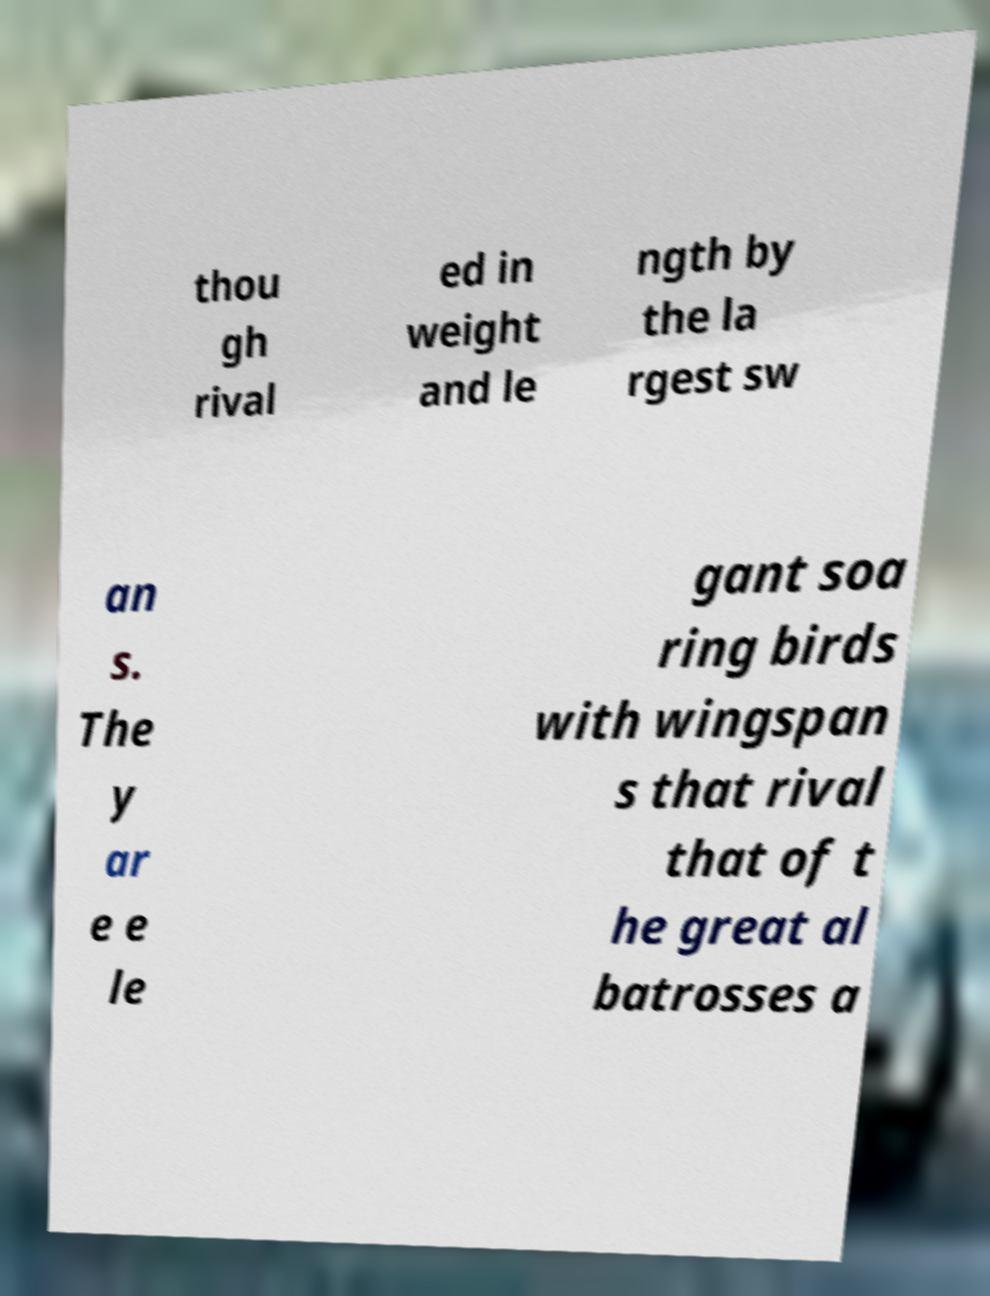Can you read and provide the text displayed in the image?This photo seems to have some interesting text. Can you extract and type it out for me? thou gh rival ed in weight and le ngth by the la rgest sw an s. The y ar e e le gant soa ring birds with wingspan s that rival that of t he great al batrosses a 